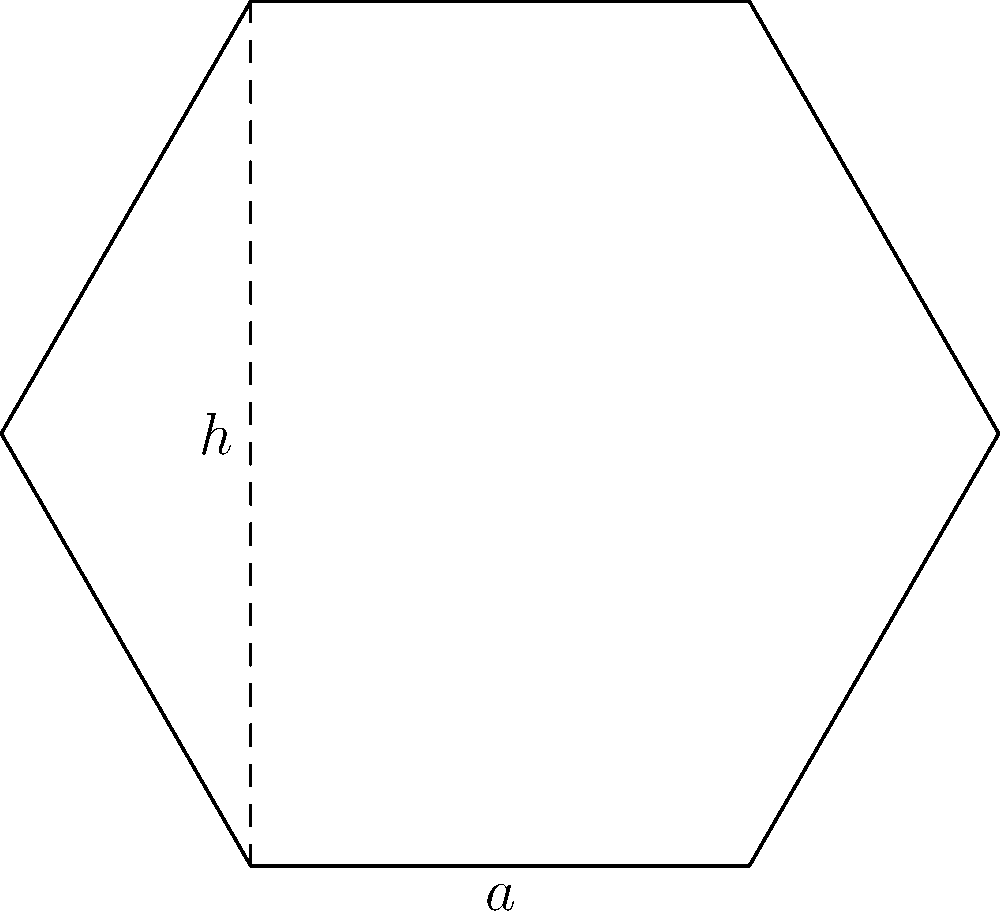Jack Grealish is designing a new soccer ball with hexagonal panels. If each panel has a side length of 4 cm and a height (distance from the center to any side) of 3.5 cm, what is the area of one hexagonal panel? To find the area of a regular hexagon, we can use the formula:

$$A = 3\sqrt{3} \cdot a^2 / 2$$

Where $a$ is the side length of the hexagon.

Given:
- Side length ($a$) = 4 cm
- Height ($h$) = 3.5 cm

Step 1: Substitute the side length into the formula:
$$A = 3\sqrt{3} \cdot (4 \text{ cm})^2 / 2$$

Step 2: Simplify:
$$A = 3\sqrt{3} \cdot 16 \text{ cm}^2 / 2$$
$$A = 24\sqrt{3} \text{ cm}^2$$

Step 3: Calculate the approximate value:
$$A \approx 41.57 \text{ cm}^2$$

Therefore, the area of one hexagonal panel is approximately 41.57 square centimeters.

Note: We can verify this result using the height:
$$A = 6 \cdot (1/2 \cdot a \cdot h) = 6 \cdot (1/2 \cdot 4 \text{ cm} \cdot 3.5 \text{ cm}) = 42 \text{ cm}^2$$
The slight difference is due to rounding in the height measurement.
Answer: 41.57 cm² 